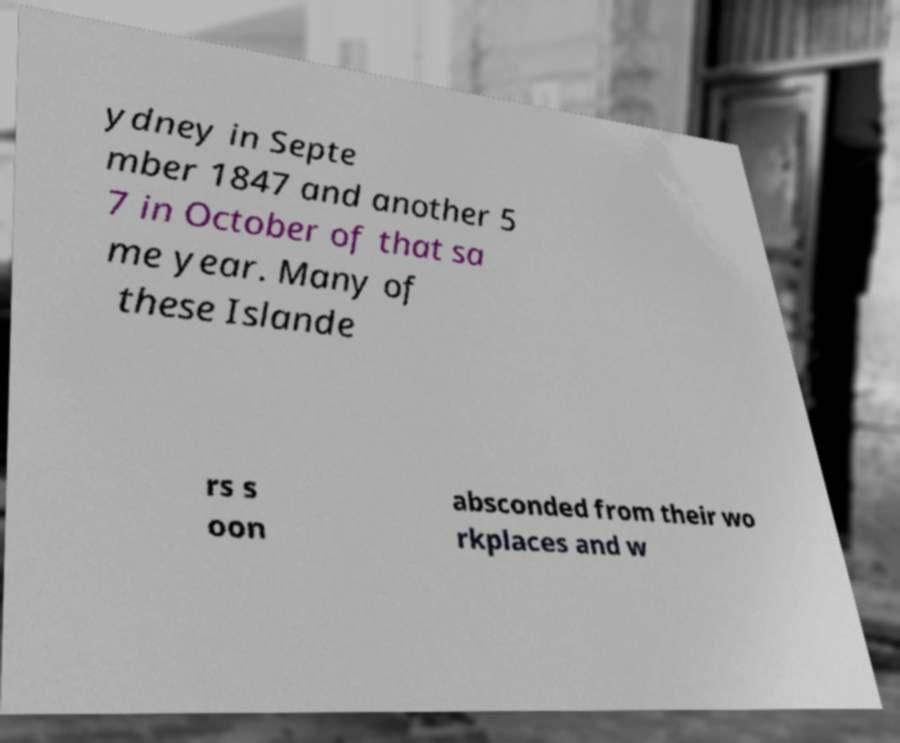Can you read and provide the text displayed in the image?This photo seems to have some interesting text. Can you extract and type it out for me? ydney in Septe mber 1847 and another 5 7 in October of that sa me year. Many of these Islande rs s oon absconded from their wo rkplaces and w 